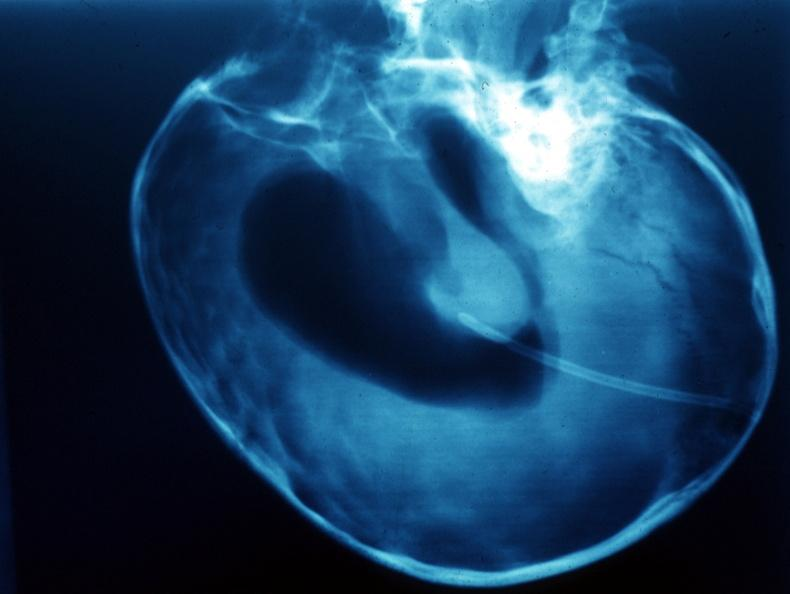what does this image show?
Answer the question using a single word or phrase. X-ray air contrast showing enlarged lateral ventricles 